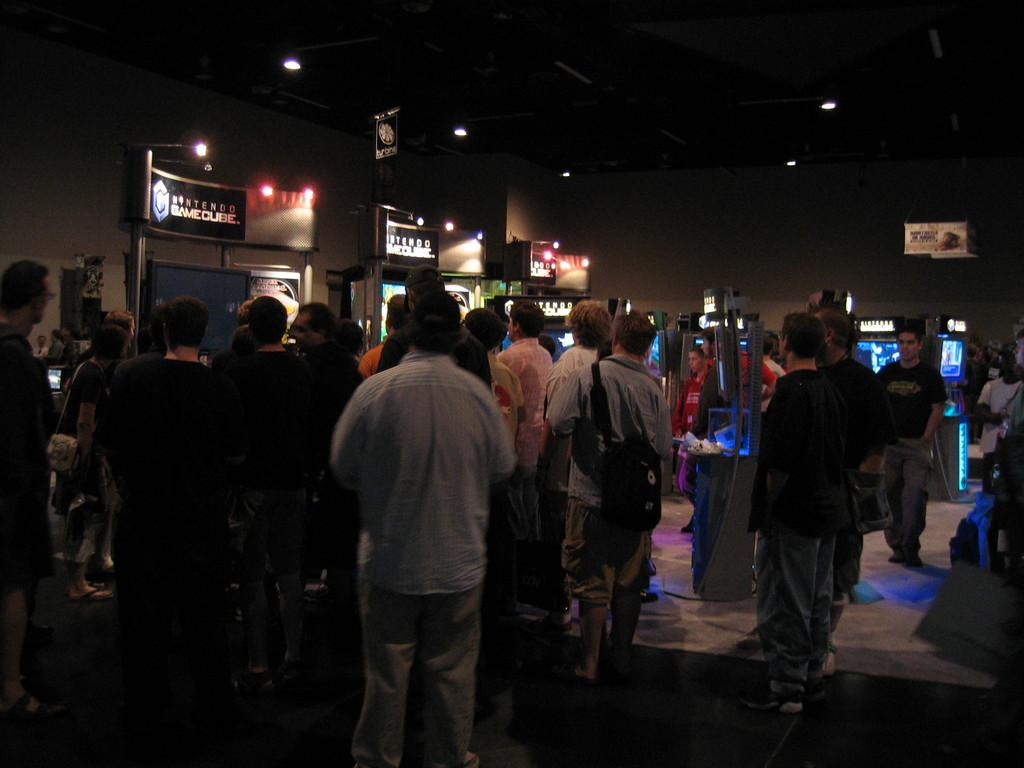What can be seen in the image involving people? There are people standing in the image. What is visible in the background of the image? There is a wall in the background of the image. What type of technology is present in the image? There are screens visible in the image. What is located at the top of the image? There are lights at the top of the image. Can you see any veins in the image? There are no veins visible in the image; it features people standing, a wall, screens, and lights. What type of beam is supporting the structure in the image? There is no beam present in the image; it only shows people, a wall, screens, and lights. 